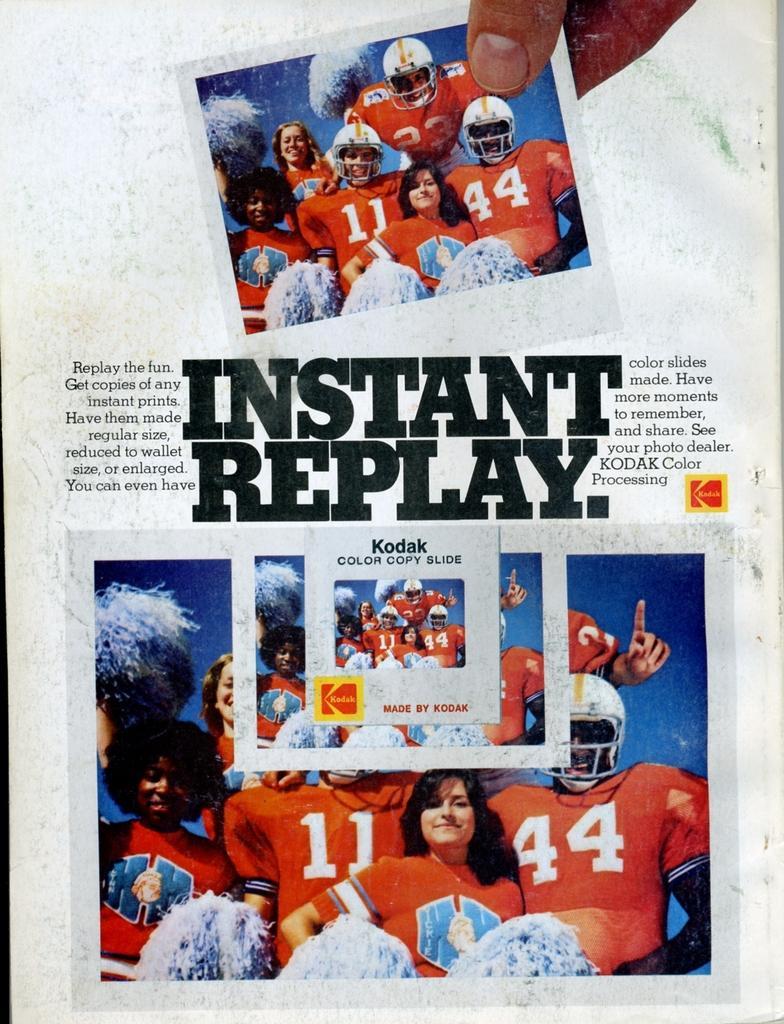Please provide a concise description of this image. In this picture I can observe some text and two photographs in the paper. In these photographs I can observe some players. The background is in white color. 